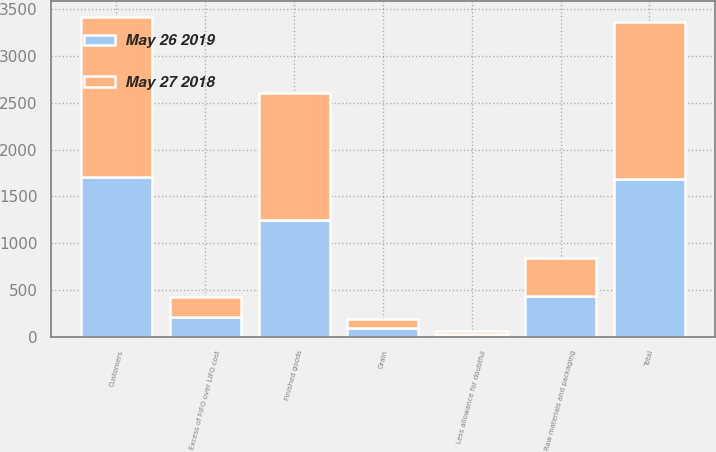<chart> <loc_0><loc_0><loc_500><loc_500><stacked_bar_chart><ecel><fcel>Customers<fcel>Less allowance for doubtful<fcel>Total<fcel>Raw materials and packaging<fcel>Finished goods<fcel>Grain<fcel>Excess of FIFO over LIFO cost<nl><fcel>May 26 2019<fcel>1708.5<fcel>28.8<fcel>1679.7<fcel>434.9<fcel>1245.9<fcel>92<fcel>213.5<nl><fcel>May 27 2018<fcel>1712.6<fcel>28.4<fcel>1684.2<fcel>400<fcel>1364.2<fcel>91.2<fcel>213.2<nl></chart> 